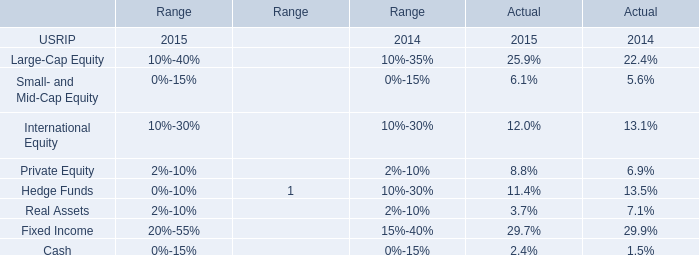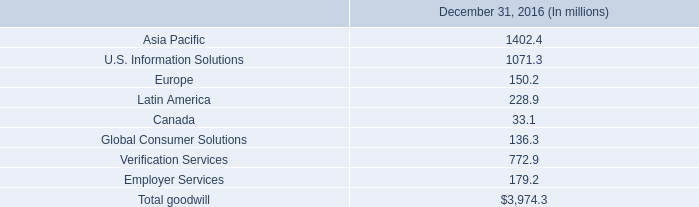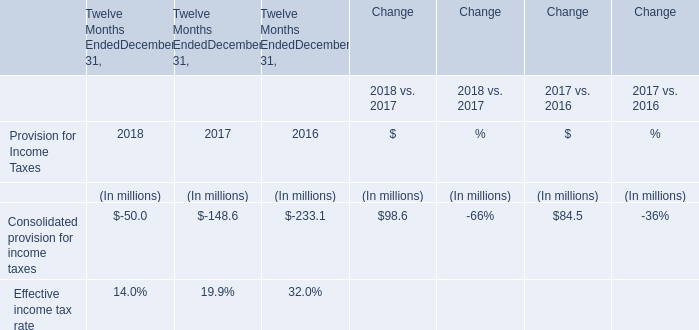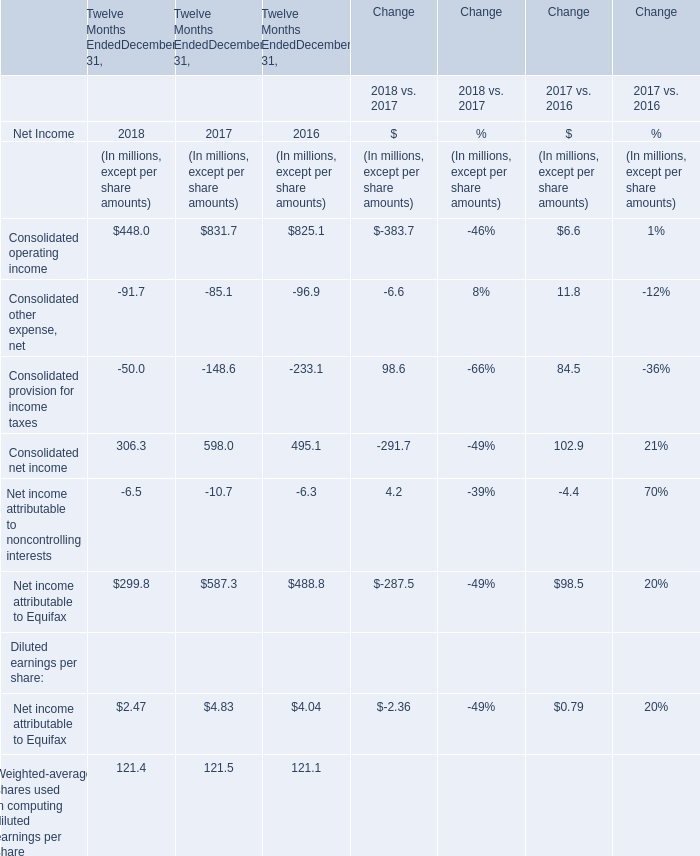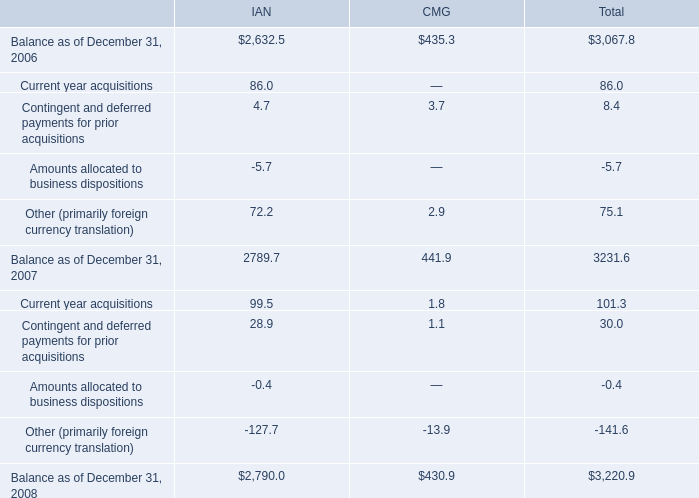What is the ratio of Consolidated provision for income taxes in Table 2 to the Consolidated other expense, net in Table 3 in 2017? 
Computations: (-148.6 / -85.1)
Answer: 1.74618. 